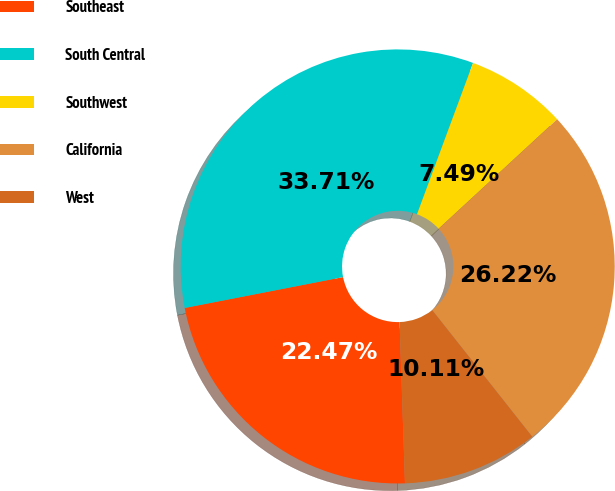<chart> <loc_0><loc_0><loc_500><loc_500><pie_chart><fcel>Southeast<fcel>South Central<fcel>Southwest<fcel>California<fcel>West<nl><fcel>22.47%<fcel>33.71%<fcel>7.49%<fcel>26.22%<fcel>10.11%<nl></chart> 